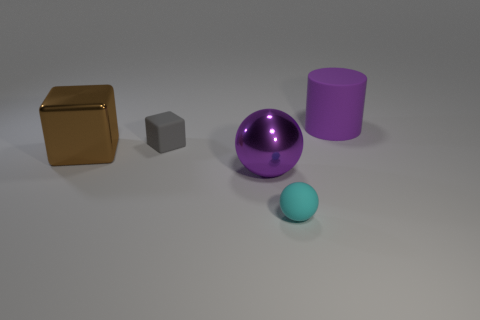Add 3 gray rubber cubes. How many objects exist? 8 Subtract all balls. How many objects are left? 3 Add 2 large purple shiny spheres. How many large purple shiny spheres are left? 3 Add 5 gray cubes. How many gray cubes exist? 6 Subtract 0 red blocks. How many objects are left? 5 Subtract all large purple things. Subtract all gray rubber objects. How many objects are left? 2 